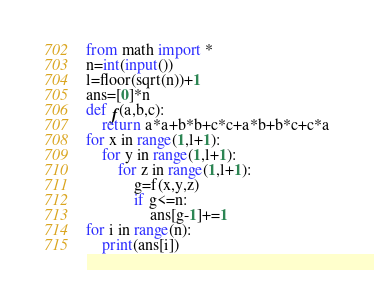<code> <loc_0><loc_0><loc_500><loc_500><_Python_>from math import *
n=int(input())
l=floor(sqrt(n))+1
ans=[0]*n
def f(a,b,c):
    return a*a+b*b+c*c+a*b+b*c+c*a
for x in range(1,l+1):
    for y in range(1,l+1):
        for z in range(1,l+1):
            g=f(x,y,z)
            if g<=n:
                ans[g-1]+=1
for i in range(n):
    print(ans[i])</code> 